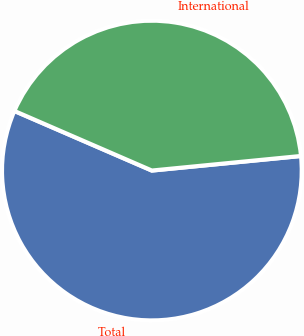Convert chart to OTSL. <chart><loc_0><loc_0><loc_500><loc_500><pie_chart><fcel>Total<fcel>International<nl><fcel>58.06%<fcel>41.94%<nl></chart> 